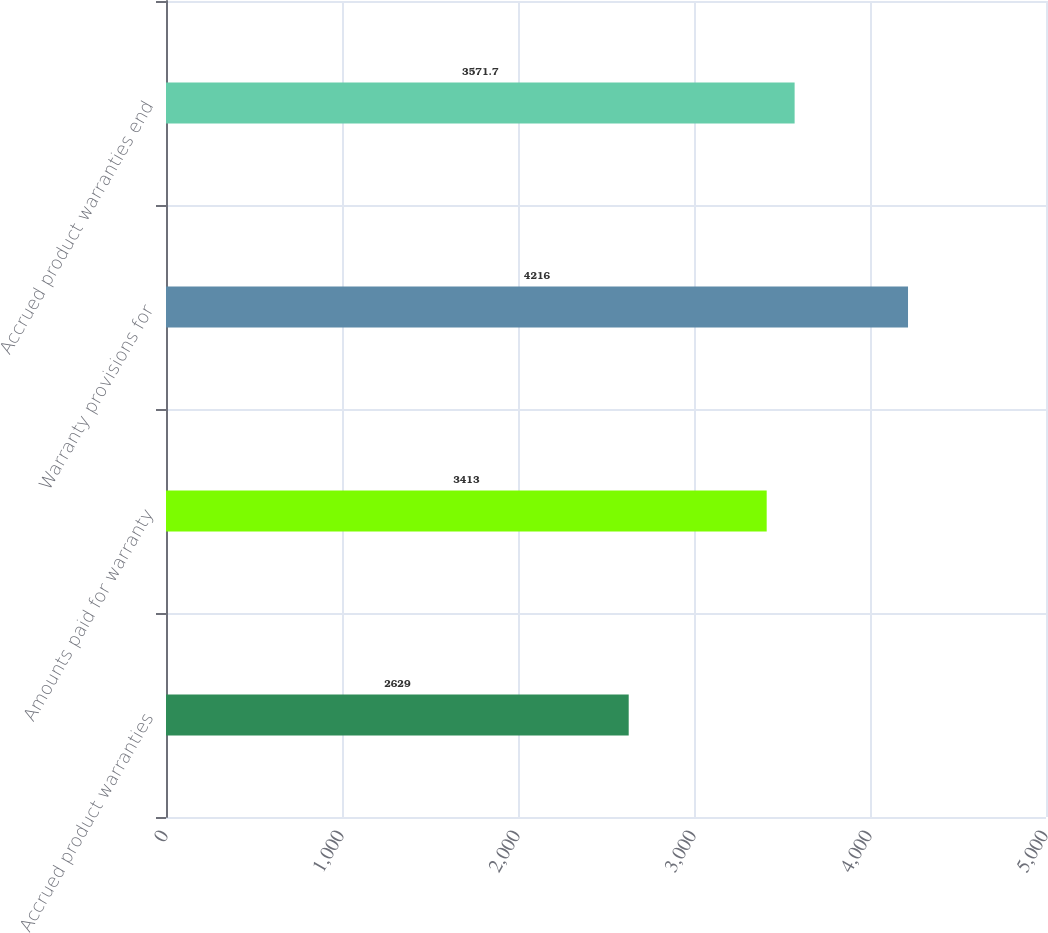Convert chart to OTSL. <chart><loc_0><loc_0><loc_500><loc_500><bar_chart><fcel>Accrued product warranties<fcel>Amounts paid for warranty<fcel>Warranty provisions for<fcel>Accrued product warranties end<nl><fcel>2629<fcel>3413<fcel>4216<fcel>3571.7<nl></chart> 